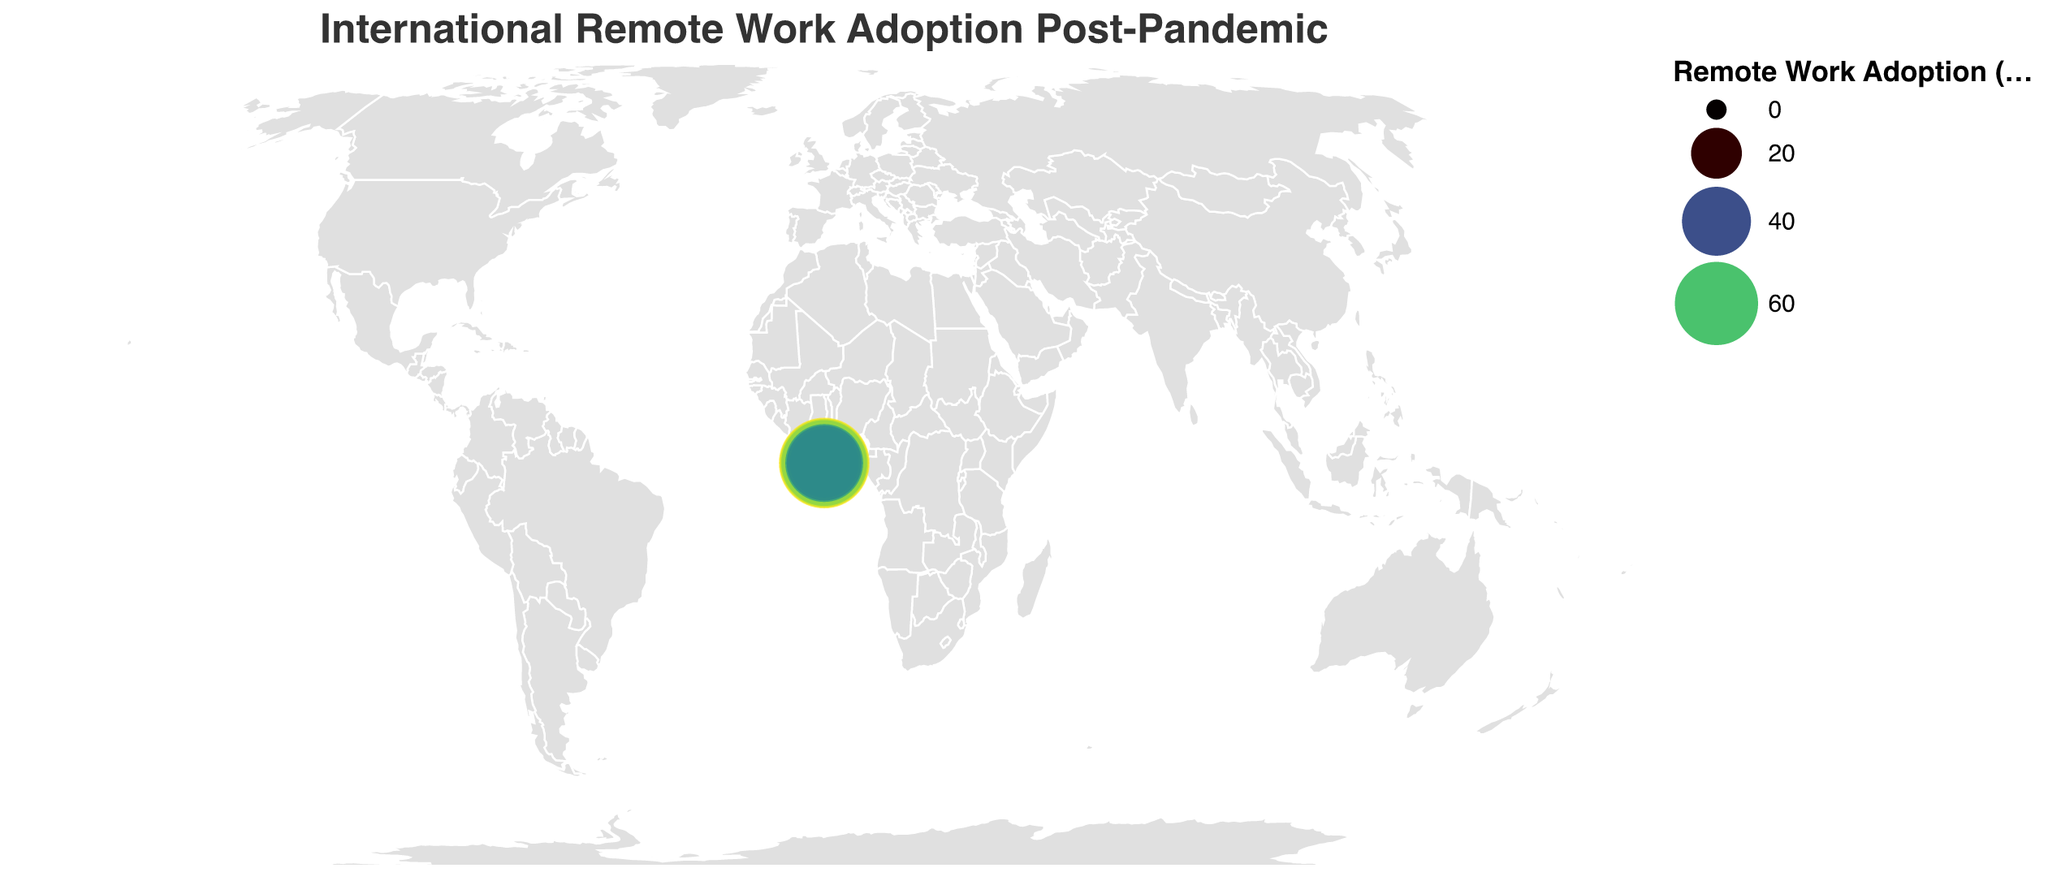How many countries are represented in the plot? Count the number of unique countries listed in the data. There are 15 countries.
Answer: 15 Which country has the highest remote work adoption percentage? Locate the country with the highest percentage value in the "Remote Work Adoption (%)" column. Sweden has the highest percentage at 72%.
Answer: Sweden What is the difference in remote work adoption between the United States and Japan? Subtract Japan's remote work adoption percentage from the United States'. The difference is 65% - 30% = 35%.
Answer: 35% Which industry faces the challenge of 'Cybersecurity', and what is the remote work adoption percentage in that industry? Identify the country with 'Cybersecurity' listed as the challenge and check its corresponding adoption percentage. Singapore faces 'Cybersecurity' challenges with a 68% remote work adoption.
Answer: Singapore, 68% What is the average remote work adoption percentage across all countries? Sum the remote work adoption percentages of all countries and divide by the number of countries. The sum is 65 + 58 + 45 + 30 + 60 + 70 + 62 + 55 + 50 + 72 + 68 + 40 + 64 + 52 + 48 = 839. The average is 839 / 15 ≈ 55.93%.
Answer: 55.93% Which countries have remote work adoption percentages greater than 60%? Identify all countries with percentages greater than 60% in the data. They are the United States (65%), India (70%), Canada (62%), Sweden (72%), Singapore (68%), and Netherlands (64%).
Answer: United States, India, Canada, Sweden, Singapore, Netherlands Between Germany and France, which country has a higher remote work adoption percentage and what is the difference? Compare the remote work adoption percentages of Germany and France, then find the difference. Germany has 45% and France has 50%. France has a higher percentage by 50% - 45% = 5%.
Answer: France, 5% Which country focuses on the automotive industry for remote work, and what is the primary challenge faced? Find the country with 'Automotive' listed as the primary industry and look at its challenge. Japan focuses on 'Automotive' and faces 'Cultural adaptation' challenges.
Answer: Japan, Cultural adaptation 